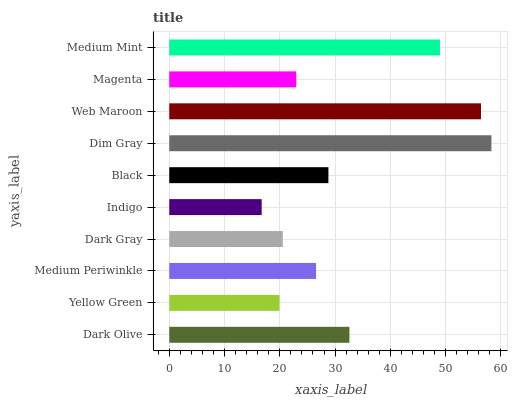Is Indigo the minimum?
Answer yes or no. Yes. Is Dim Gray the maximum?
Answer yes or no. Yes. Is Yellow Green the minimum?
Answer yes or no. No. Is Yellow Green the maximum?
Answer yes or no. No. Is Dark Olive greater than Yellow Green?
Answer yes or no. Yes. Is Yellow Green less than Dark Olive?
Answer yes or no. Yes. Is Yellow Green greater than Dark Olive?
Answer yes or no. No. Is Dark Olive less than Yellow Green?
Answer yes or no. No. Is Black the high median?
Answer yes or no. Yes. Is Medium Periwinkle the low median?
Answer yes or no. Yes. Is Yellow Green the high median?
Answer yes or no. No. Is Medium Mint the low median?
Answer yes or no. No. 